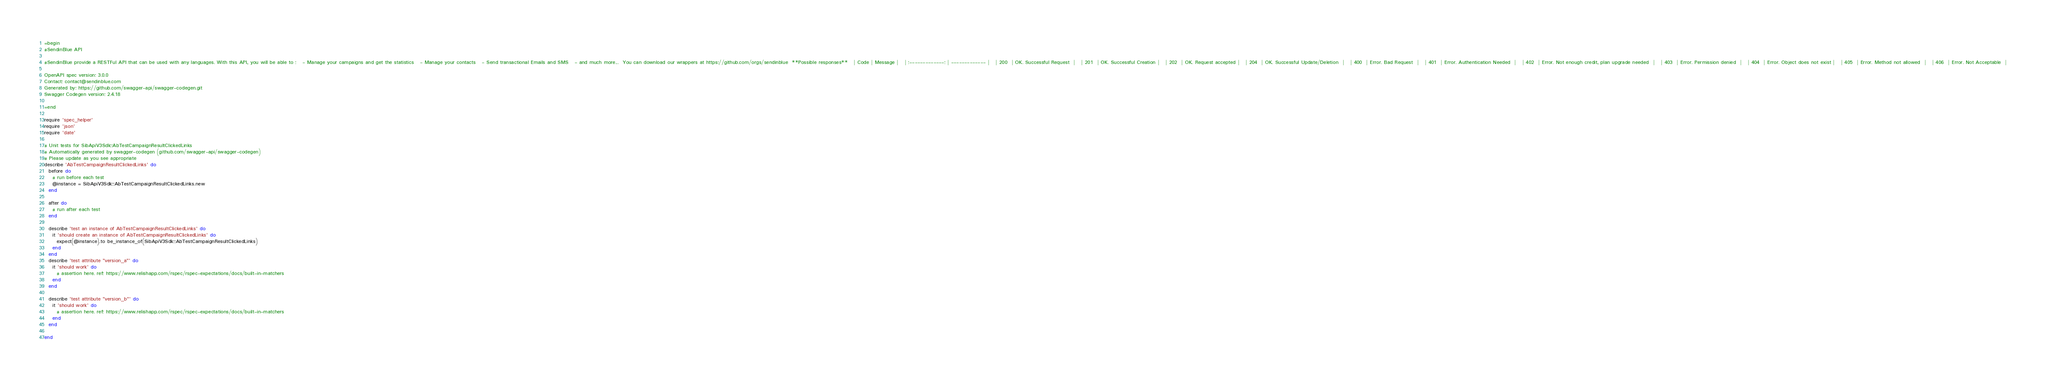<code> <loc_0><loc_0><loc_500><loc_500><_Ruby_>=begin
#SendinBlue API

#SendinBlue provide a RESTFul API that can be used with any languages. With this API, you will be able to :   - Manage your campaigns and get the statistics   - Manage your contacts   - Send transactional Emails and SMS   - and much more...  You can download our wrappers at https://github.com/orgs/sendinblue  **Possible responses**   | Code | Message |   | :-------------: | ------------- |   | 200  | OK. Successful Request  |   | 201  | OK. Successful Creation |   | 202  | OK. Request accepted |   | 204  | OK. Successful Update/Deletion  |   | 400  | Error. Bad Request  |   | 401  | Error. Authentication Needed  |   | 402  | Error. Not enough credit, plan upgrade needed  |   | 403  | Error. Permission denied  |   | 404  | Error. Object does not exist |   | 405  | Error. Method not allowed  |   | 406  | Error. Not Acceptable  | 

OpenAPI spec version: 3.0.0
Contact: contact@sendinblue.com
Generated by: https://github.com/swagger-api/swagger-codegen.git
Swagger Codegen version: 2.4.18

=end

require 'spec_helper'
require 'json'
require 'date'

# Unit tests for SibApiV3Sdk::AbTestCampaignResultClickedLinks
# Automatically generated by swagger-codegen (github.com/swagger-api/swagger-codegen)
# Please update as you see appropriate
describe 'AbTestCampaignResultClickedLinks' do
  before do
    # run before each test
    @instance = SibApiV3Sdk::AbTestCampaignResultClickedLinks.new
  end

  after do
    # run after each test
  end

  describe 'test an instance of AbTestCampaignResultClickedLinks' do
    it 'should create an instance of AbTestCampaignResultClickedLinks' do
      expect(@instance).to be_instance_of(SibApiV3Sdk::AbTestCampaignResultClickedLinks)
    end
  end
  describe 'test attribute "version_a"' do
    it 'should work' do
      # assertion here. ref: https://www.relishapp.com/rspec/rspec-expectations/docs/built-in-matchers
    end
  end

  describe 'test attribute "version_b"' do
    it 'should work' do
      # assertion here. ref: https://www.relishapp.com/rspec/rspec-expectations/docs/built-in-matchers
    end
  end

end
</code> 